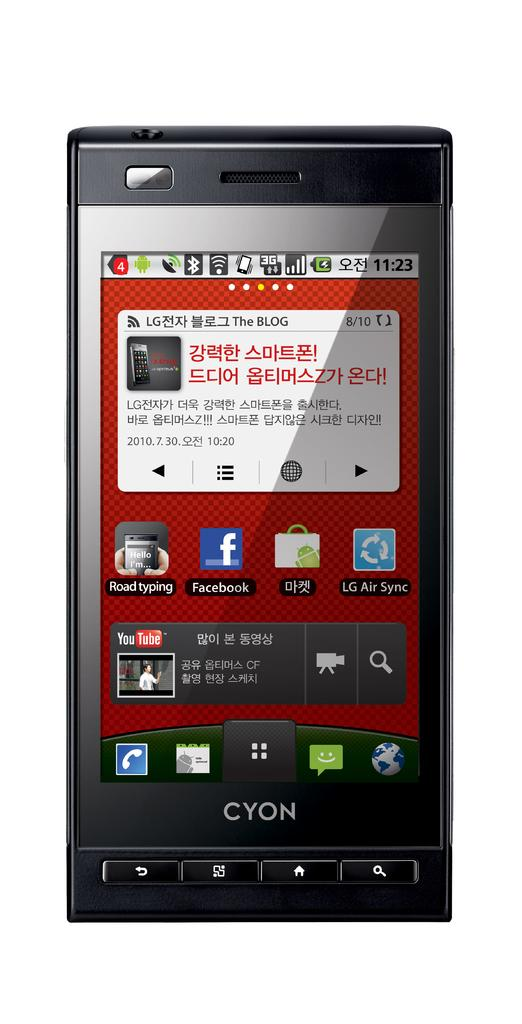<image>
Relay a brief, clear account of the picture shown. A black Cyon cell phone with red Chinese writing in red in a white box. 